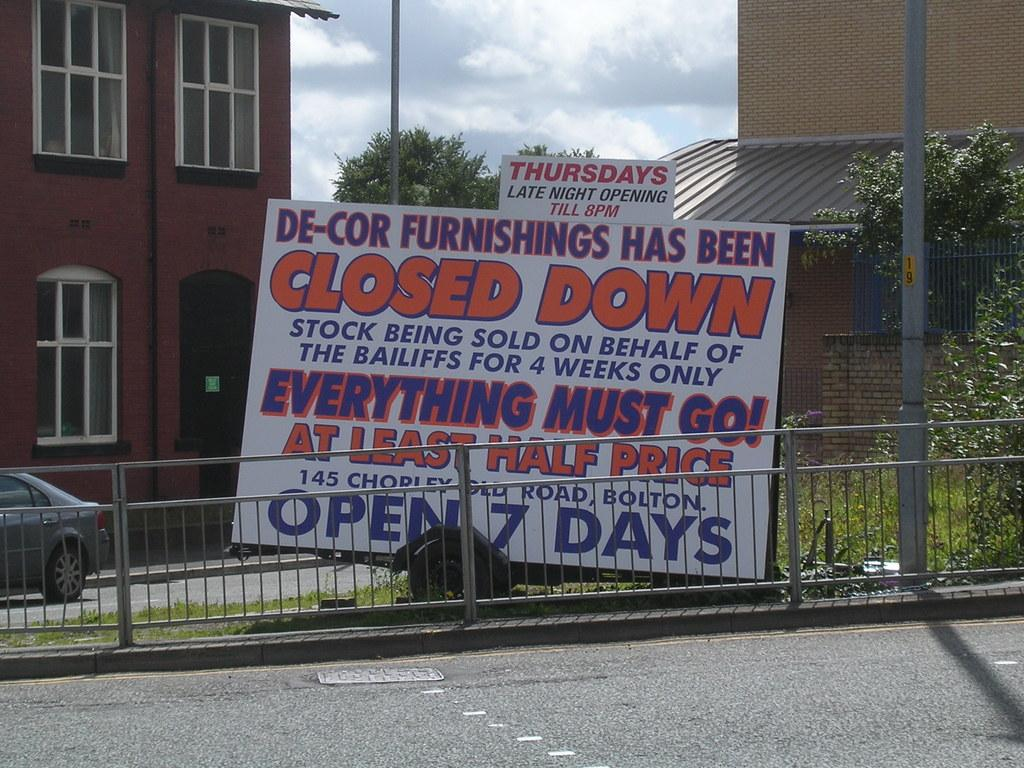What is the main feature of the image? There is a road in the image. What is located in the middle of the road? There is a poster in the middle of the road. What can be seen in the background of the image? There is a building visible in the background of the image. What type of toothpaste is advertised on the poster in the image? There is no toothpaste mentioned or advertised on the poster in the image. 